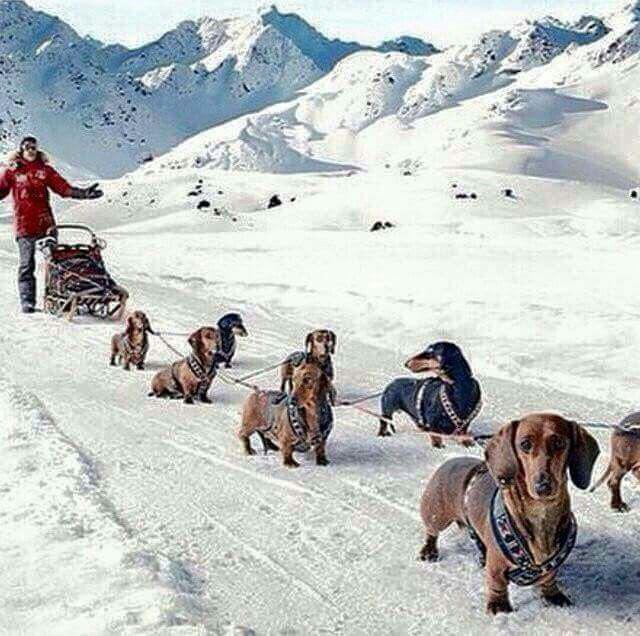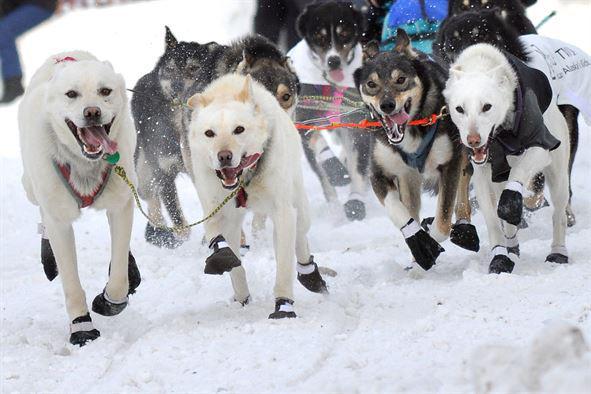The first image is the image on the left, the second image is the image on the right. Evaluate the accuracy of this statement regarding the images: "The right image features multiple husky dogs with dark-and-white fur and no booties racing toward the camera with tongues hanging out.". Is it true? Answer yes or no. No. 